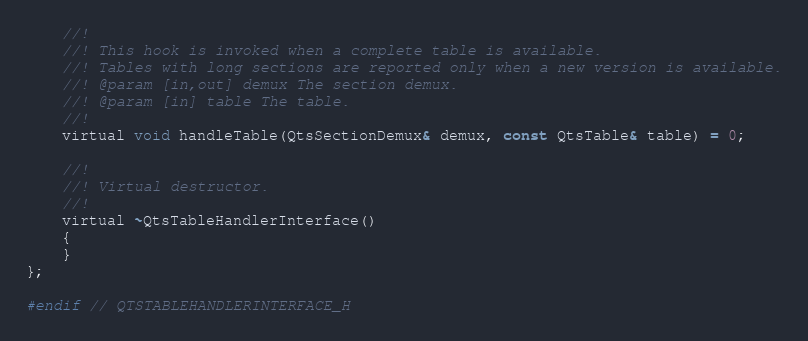<code> <loc_0><loc_0><loc_500><loc_500><_C_>    //!
    //! This hook is invoked when a complete table is available.
    //! Tables with long sections are reported only when a new version is available.
    //! @param [in,out] demux The section demux.
    //! @param [in] table The table.
    //!
    virtual void handleTable(QtsSectionDemux& demux, const QtsTable& table) = 0;

    //!
    //! Virtual destructor.
    //!
    virtual ~QtsTableHandlerInterface()
    {
    }
};

#endif // QTSTABLEHANDLERINTERFACE_H
</code> 